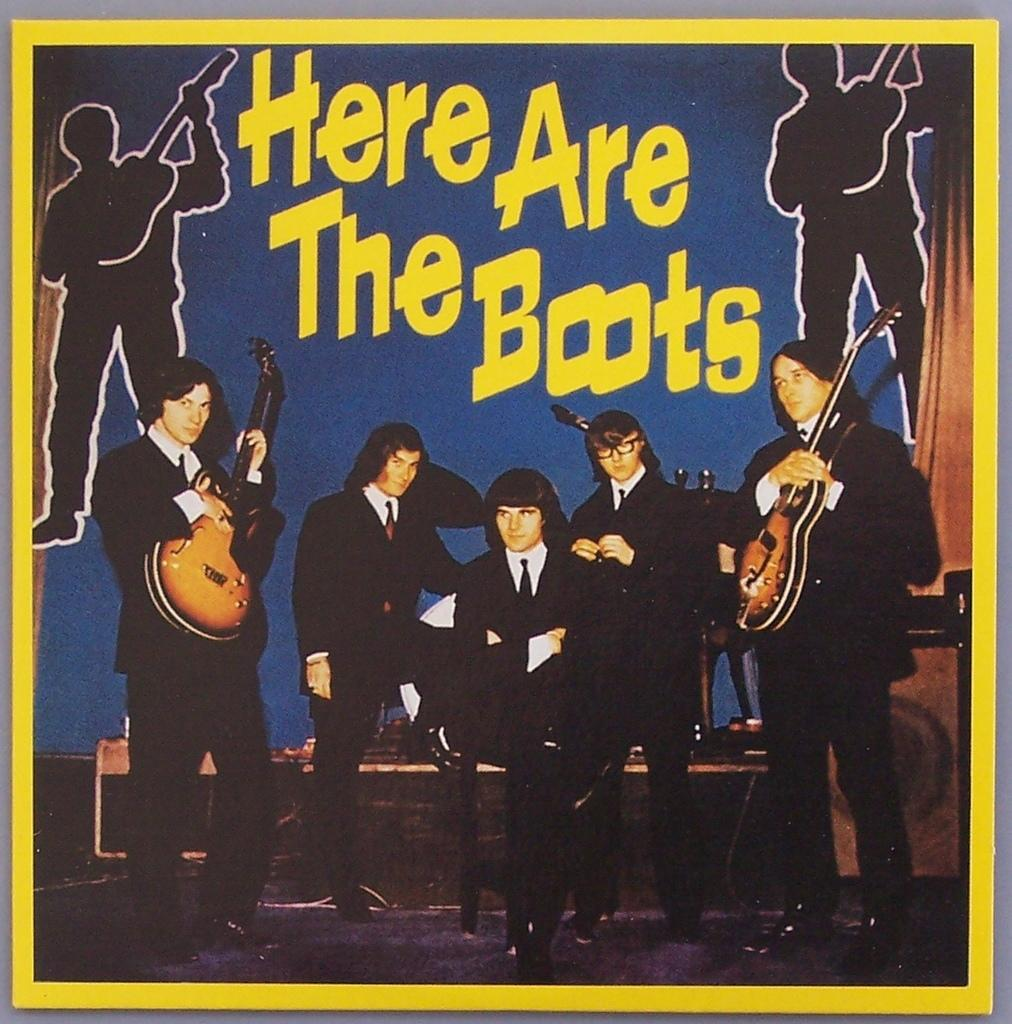How many people are in the image? There are people in the image, but the exact number is not specified. What are the people doing in the image? The people are holding musical instruments in their hands. What type of agreement was reached during the division of the basin in the image? There is no mention of an agreement, division, or basin in the image. 